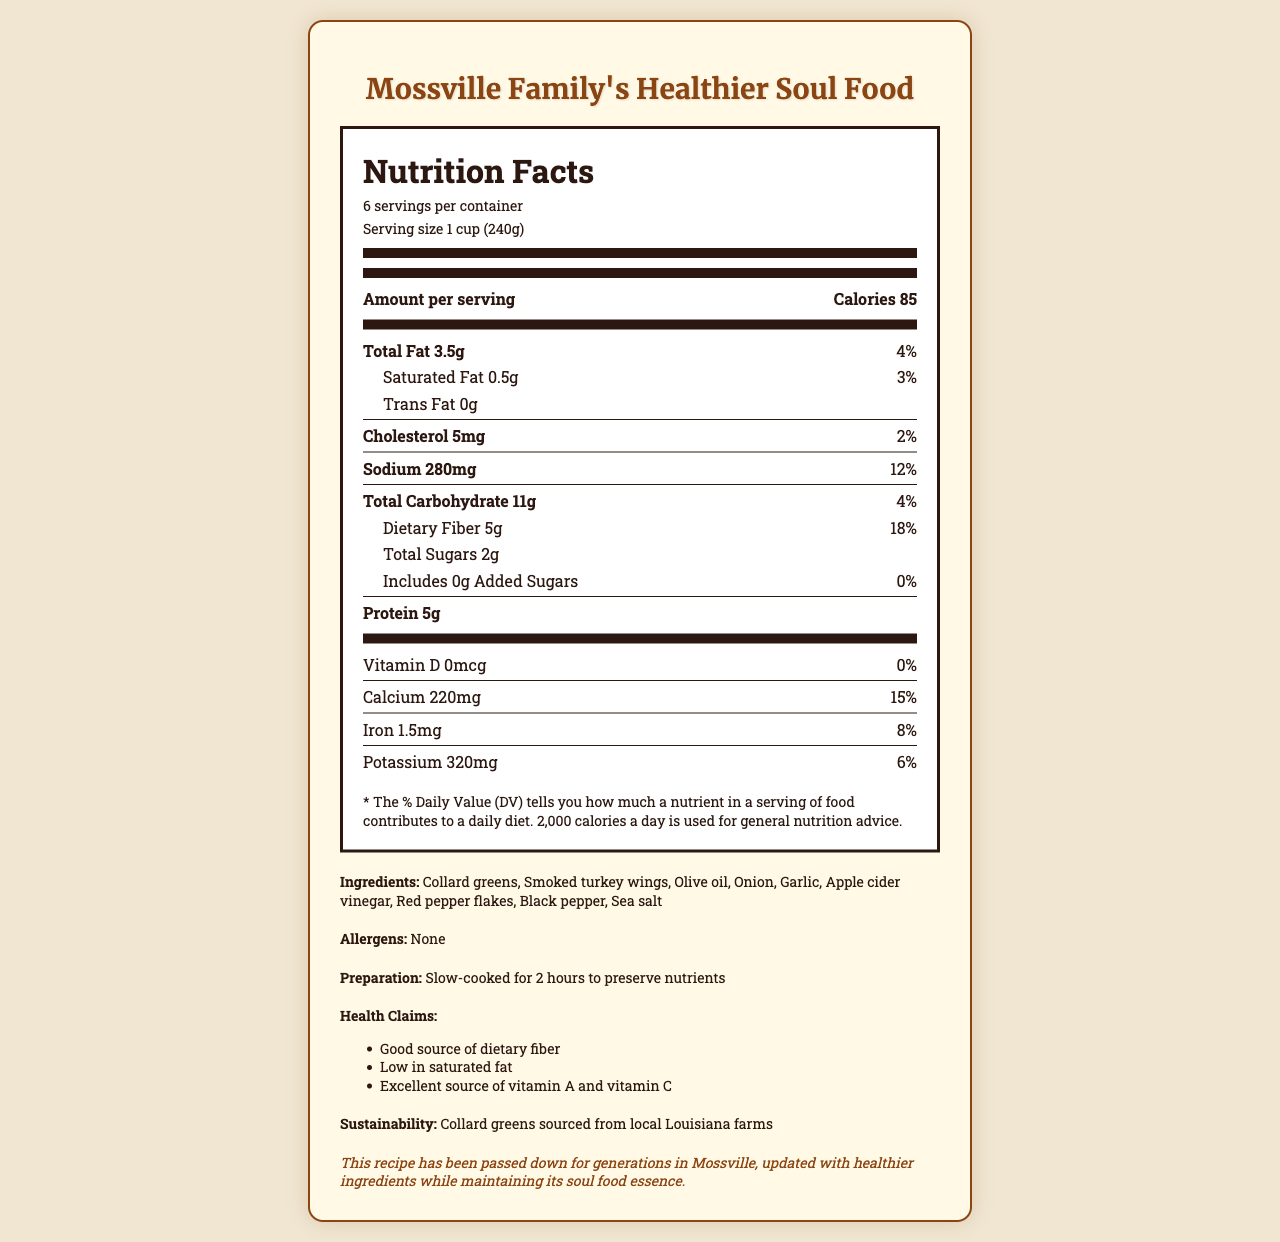what is the serving size of the dish? The serving size is clearly stated as "1 cup (240g)" in the document.
Answer: 1 cup (240g) how many servings are in the container? The document specifies that there are 6 servings per container.
Answer: 6 how many calories are in one serving? The nutrition label indicates that there are 85 calories per serving.
Answer: 85 how much dietary fiber is present in one serving? The document lists the amount of dietary fiber as 5g per serving.
Answer: 5g what percentage of the daily value of sodium does one serving provide? The sodium content per serving is provided as 280mg, which is 12% of the daily value.
Answer: 12% which ingredient is used for adding a smoky flavor to the dish? Among the listed ingredients, smoked turkey wings are used to add a smoky flavor.
Answer: Smoked turkey wings what allergens are present in the dish? The allergen section clearly states "None".
Answer: None how long is the dish cooked to preserve nutrients? The preparation notes mention that the dish is slow-cooked for 2 hours to preserve nutrients.
Answer: 2 hours which vitamin is not present in the dish? A. Vitamin D B. Vitamin A C. Vitamin C D. Iron According to the nutrition label, Vitamin D is listed as 0mcg.
Answer: A. Vitamin D what is the protein content per serving? The document states that each serving contains 5g of protein.
Answer: 5g how much total fat is in one serving? The total fat content per serving is 3.5g as per the nutritional information.
Answer: 3.5g is there any added sugar in the dish? The document indicates that the amount of added sugars is 0g.
Answer: No what are the main ingredients of the dish? The document lists these ingredients under the ingredients section.
Answer: Collard greens, Smoked turkey wings, Olive oil, Onion, Garlic, Apple cider vinegar, Red pepper flakes, Black pepper, Sea salt how much calcium does one serving provide? The nutritional label provides the calcium amount as 220mg per serving.
Answer: 220mg is the dish high in saturated fat? The document states that the dish is low in saturated fat with only 0.5g per serving.
Answer: No what is the cultural significance of the dish? The cultural significance section explains that the recipe has been passed down for generations and updated with healthier ingredients.
Answer: This recipe has been passed down for generations in Mossville, updated with healthier ingredients while maintaining its soul food essence. how is sustainability addressed in the dish? The document mentions that the collard greens are sourced from local Louisiana farms, indicating sustainability efforts.
Answer: Collard greens sourced from local Louisiana farms which of these health claims are true about the dish? A. Good source of dietary fiber B. Low in cholesterol C. Excellent source of vitamin A and vitamin C D. Low in sodium The health claims section clearly lists "Good source of dietary fiber" and "Excellent source of vitamin A and vitamin C".
Answer: A. Good source of dietary fiber C. Excellent source of vitamin A and vitamin C what percentage of the daily value of iron does one serving provide? The document states that one serving provides 1.5mg of iron, which is 8% of the daily value.
Answer: 8% how many grams of total carbohydrates are there per serving? The nutrition label mentions that there are 11g of total carbohydrates per serving.
Answer: 11g describe the entire document or the main idea of the document. The document includes a detailed nutrition facts label, consisting of serving size, calorie content, macro and micronutrient information, ingredients, and additional notes. It highlights health benefits and cultural heritage, emphasizing that the recipe has been passed down through generations and updated for better health.
Answer: The document is a nutrition facts label for "Mossville Family's Healthier Collard Greens," detailing the nutritional content, ingredients, preparation notes, health claims, cultural significance, and sustainability information for the dish. It provides insight into the efforts to make a traditional Southern soul food dish healthier while preserving its cultural essence. what is the recipe for the dish? The recipe or cooking instructions are not provided in the document; only the ingredients and preparation notes are visible.
Answer: Not enough information 